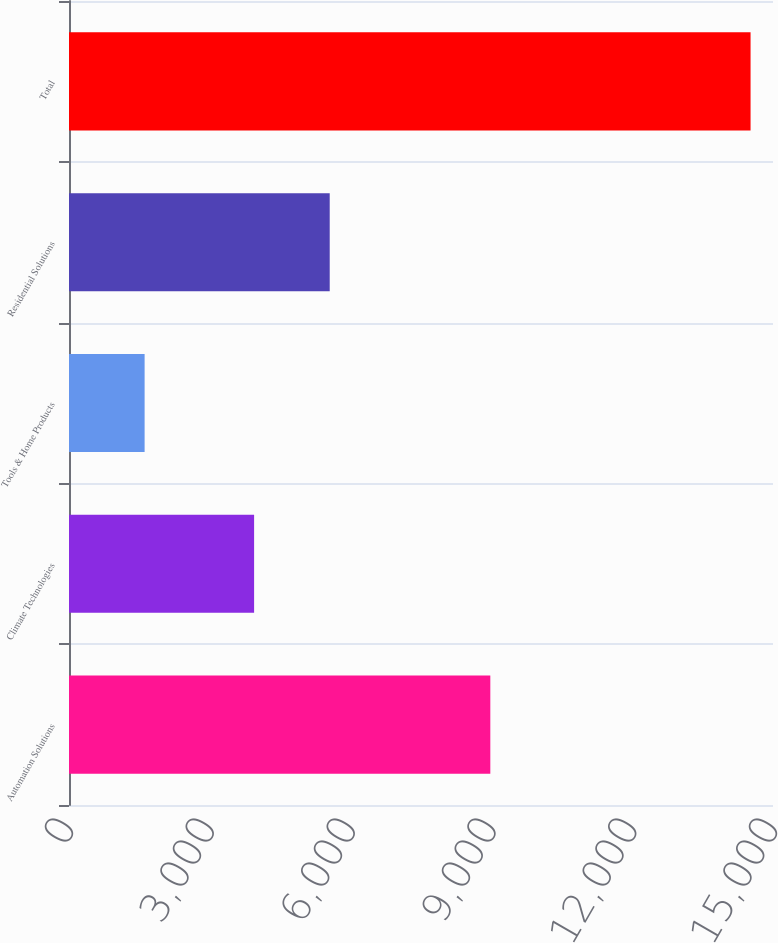Convert chart to OTSL. <chart><loc_0><loc_0><loc_500><loc_500><bar_chart><fcel>Automation Solutions<fcel>Climate Technologies<fcel>Tools & Home Products<fcel>Residential Solutions<fcel>Total<nl><fcel>8977<fcel>3944<fcel>1611<fcel>5555<fcel>14522<nl></chart> 